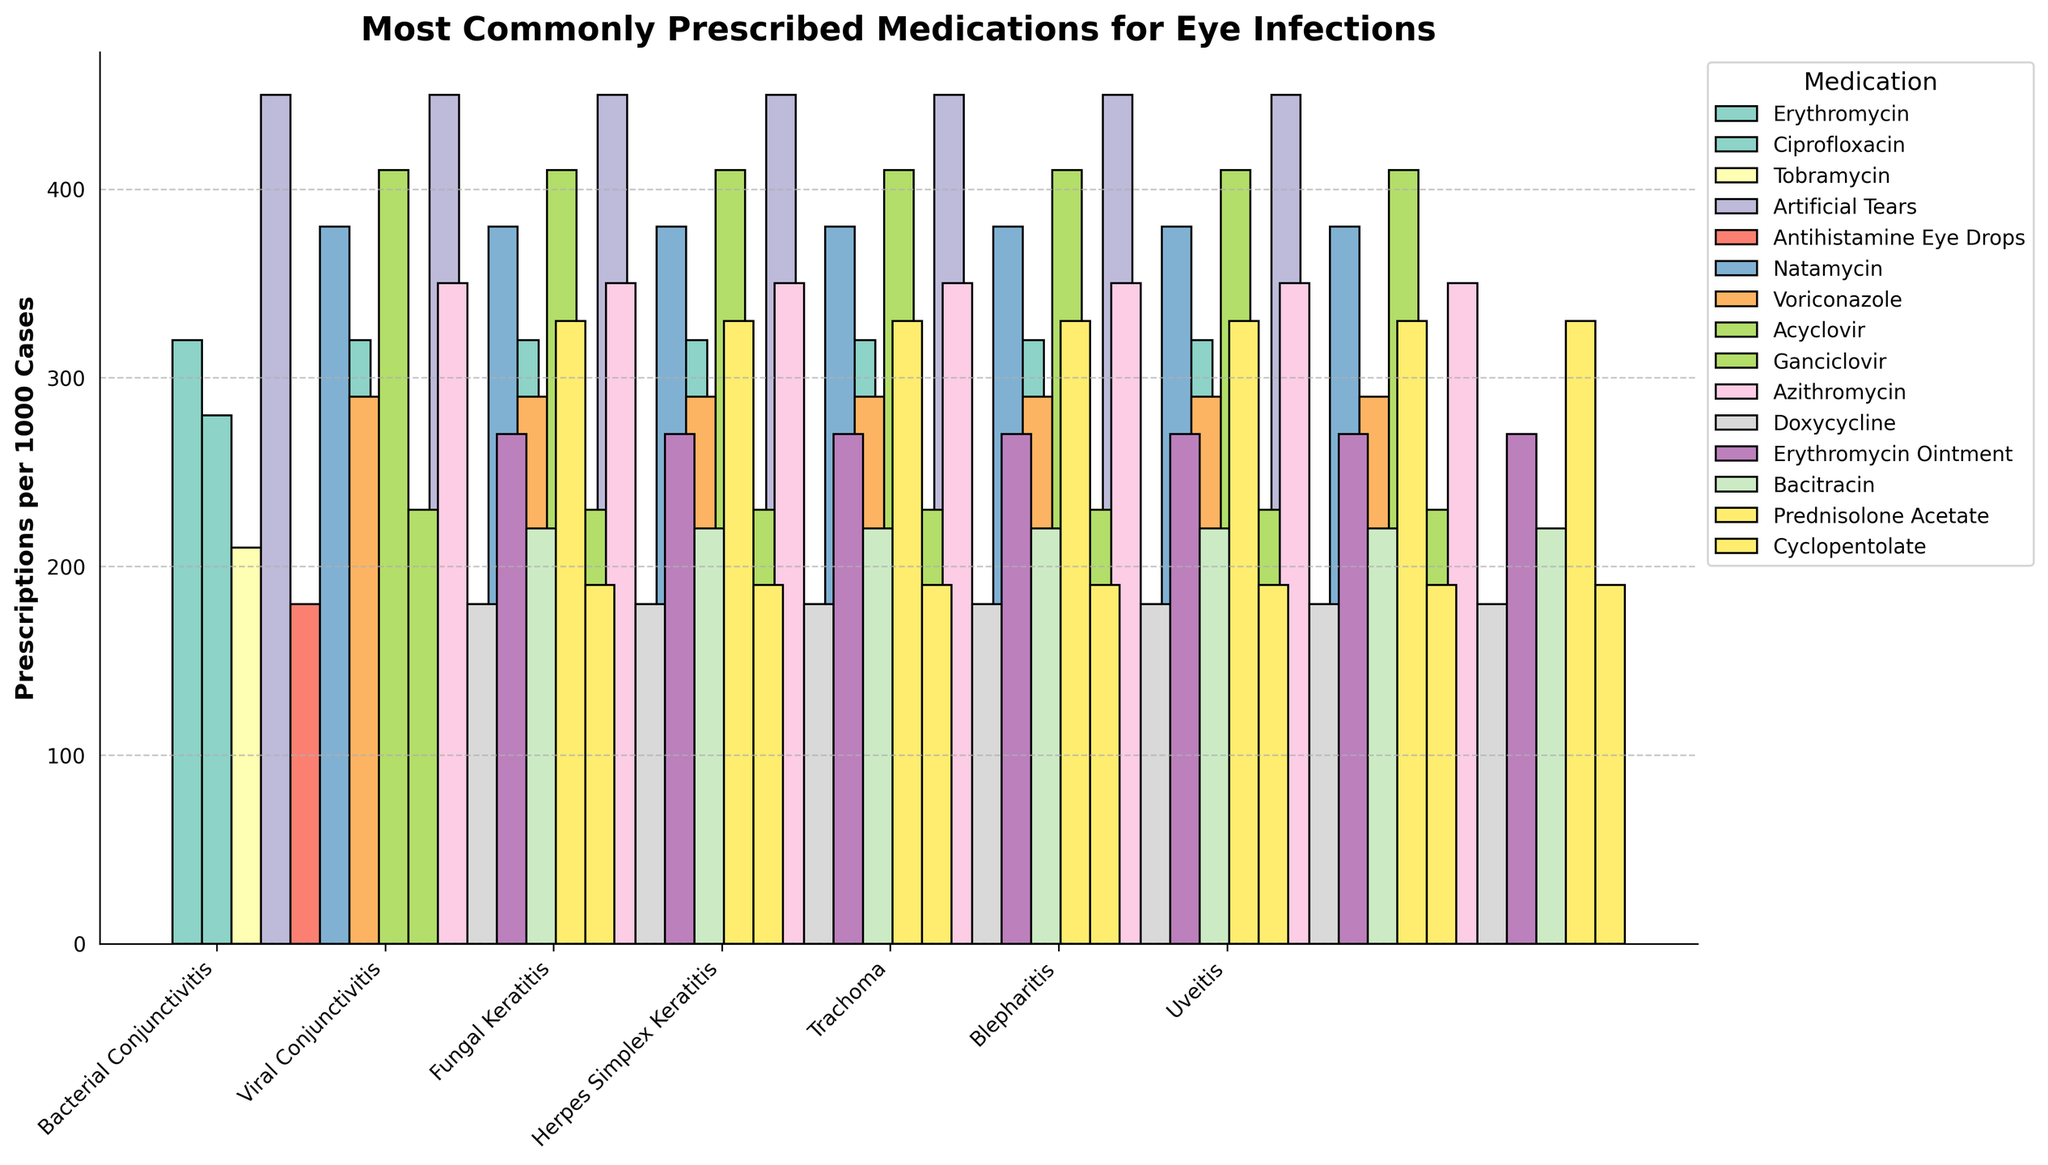Which medication has the highest number of prescriptions for viral conjunctivitis? Look at the bars corresponding to viral conjunctivitis and compare their heights. The tallest bar represents artificial tears.
Answer: Artificial Tears What is the combined number of prescriptions for erythromycin and ciprofloxacin for bacterial conjunctivitis? Identify the bars for erythromycin (320) and ciprofloxacin (280) in the bacterial conjunctivitis section. Add these values together: 320 + 280.
Answer: 600 Which infection type has the lowest number of prescriptions for any medication? Compare the shortest bars for all infection types. The shortest bar is for trachoma (Doxycycline, 180).
Answer: Trachoma How many more prescriptions are there for artificial tears for viral conjunctivitis compared to Natamycin for fungal keratitis? Find the values for artificial tears (450) and Natamycin (380). Subtract the smaller value from the larger: 450 - 380.
Answer: 70 Which medication is most commonly prescribed for herpes simplex keratitis? Look at the heights of the bars in the herpes simplex keratitis section. Acyclovir has the tallest bar.
Answer: Acyclovir What is the average number of prescriptions per medication for trachoma? Identify the two bars for trachoma (Azithromycin, 350 and Doxycycline, 180). Find the sum: 350 + 180 = 530. Then, calculate the average by dividing by 2: 530/2.
Answer: 265 Compare the prescriptions of tobramycin for bacterial conjunctivitis and ganciclovir for herpes simplex keratitis. Which one is higher? Identify the bars for tobramycin (210) and ganciclovir (230). Compare the values directly.
Answer: Ganciclovir What is the total number of prescriptions for prednisolone acetate and cyclopentolate for uveitis? Identify and sum the bars for prednisolone acetate (330) and cyclopentolate (190): 330 + 190.
Answer: 520 Which medication is used for both bacterial conjunctivitis and blepharitis? Look for a medication that appears under both bacterial conjunctivitis and blepharitis sections. Erythromycin is found in both.
Answer: Erythromycin 